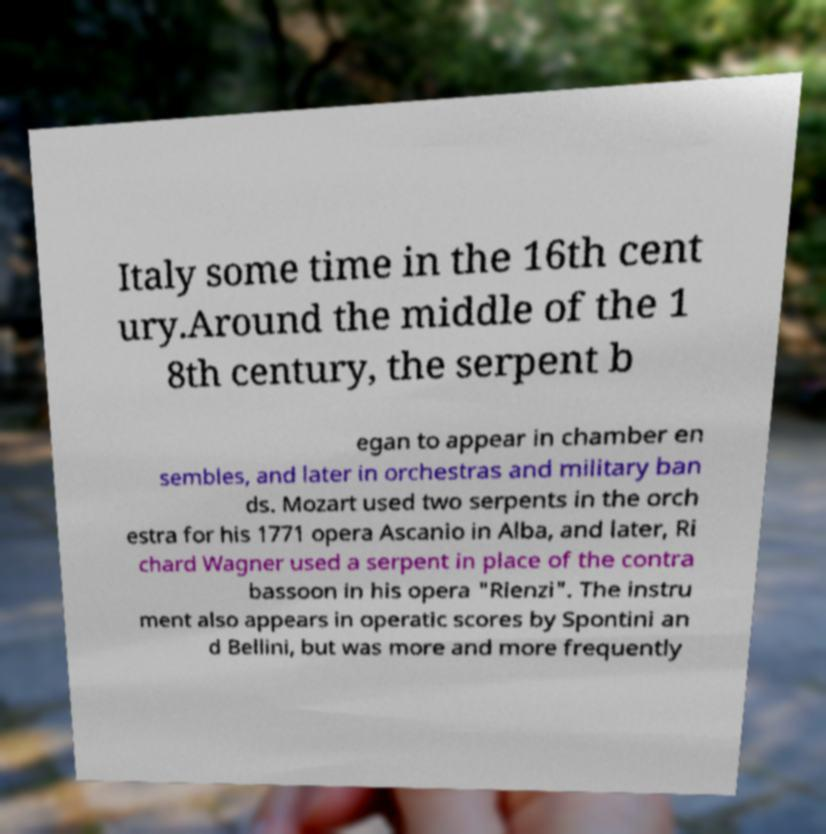There's text embedded in this image that I need extracted. Can you transcribe it verbatim? Italy some time in the 16th cent ury.Around the middle of the 1 8th century, the serpent b egan to appear in chamber en sembles, and later in orchestras and military ban ds. Mozart used two serpents in the orch estra for his 1771 opera Ascanio in Alba, and later, Ri chard Wagner used a serpent in place of the contra bassoon in his opera "Rienzi". The instru ment also appears in operatic scores by Spontini an d Bellini, but was more and more frequently 